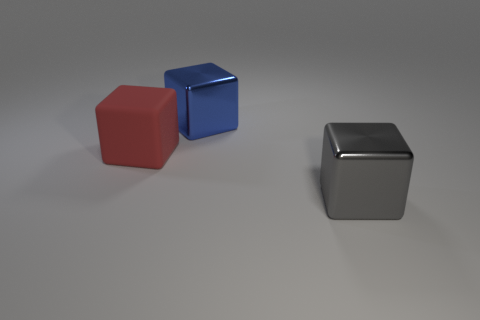How many big gray shiny cubes are behind the large metallic object that is left of the large gray cube?
Ensure brevity in your answer.  0. What is the large red thing that is to the left of the big cube in front of the red block made of?
Make the answer very short. Rubber. There is a big red thing that is the same shape as the big blue metal object; what is its material?
Provide a succinct answer. Rubber. Does the cube to the left of the blue object have the same size as the blue block?
Provide a succinct answer. Yes. What number of matte things are either gray cubes or small brown cubes?
Provide a succinct answer. 0. There is a big block that is both behind the gray metallic block and in front of the large blue block; what is its material?
Your response must be concise. Rubber. Does the blue block have the same material as the big red object?
Ensure brevity in your answer.  No. There is a block that is behind the gray shiny object and on the right side of the red rubber object; what is its size?
Ensure brevity in your answer.  Large. What is the shape of the gray thing?
Make the answer very short. Cube. How many things are either large blocks or large metallic objects that are in front of the big rubber cube?
Your answer should be very brief. 3. 